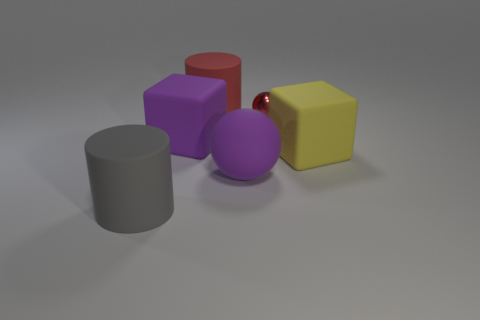Are there any other things that are made of the same material as the tiny red sphere?
Your answer should be compact. No. Are there any large gray rubber objects of the same shape as the tiny shiny object?
Provide a short and direct response. No. What is the shape of the object that is on the left side of the big purple matte cube?
Provide a succinct answer. Cylinder. How many spheres are there?
Your response must be concise. 2. The large ball that is the same material as the big yellow block is what color?
Give a very brief answer. Purple. What number of small objects are either gray things or cyan metal blocks?
Your response must be concise. 0. There is a rubber sphere; what number of large purple objects are behind it?
Offer a very short reply. 1. There is another large rubber thing that is the same shape as the big red matte object; what color is it?
Ensure brevity in your answer.  Gray. How many matte things are cylinders or yellow cylinders?
Offer a very short reply. 2. Is there a big matte cylinder that is in front of the purple object that is to the left of the cylinder that is right of the big gray thing?
Your answer should be compact. Yes. 